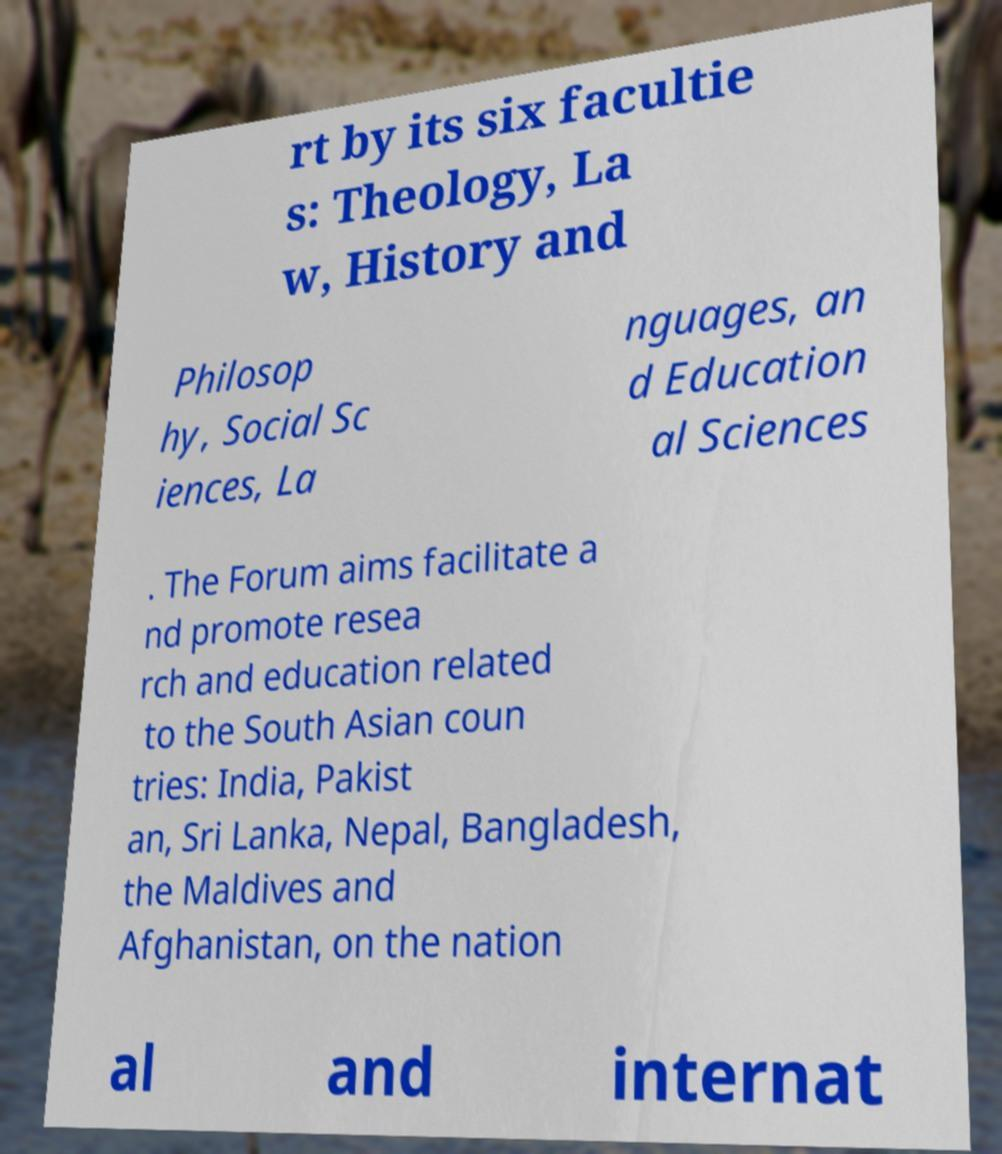Can you read and provide the text displayed in the image?This photo seems to have some interesting text. Can you extract and type it out for me? rt by its six facultie s: Theology, La w, History and Philosop hy, Social Sc iences, La nguages, an d Education al Sciences . The Forum aims facilitate a nd promote resea rch and education related to the South Asian coun tries: India, Pakist an, Sri Lanka, Nepal, Bangladesh, the Maldives and Afghanistan, on the nation al and internat 